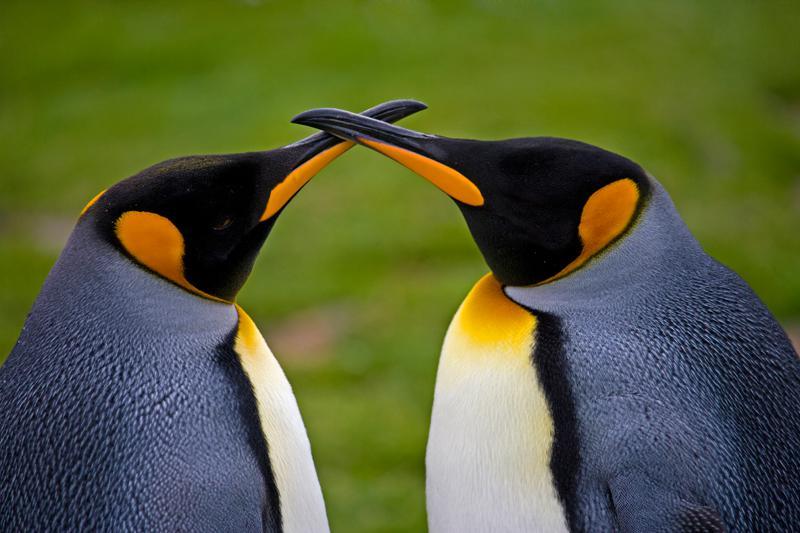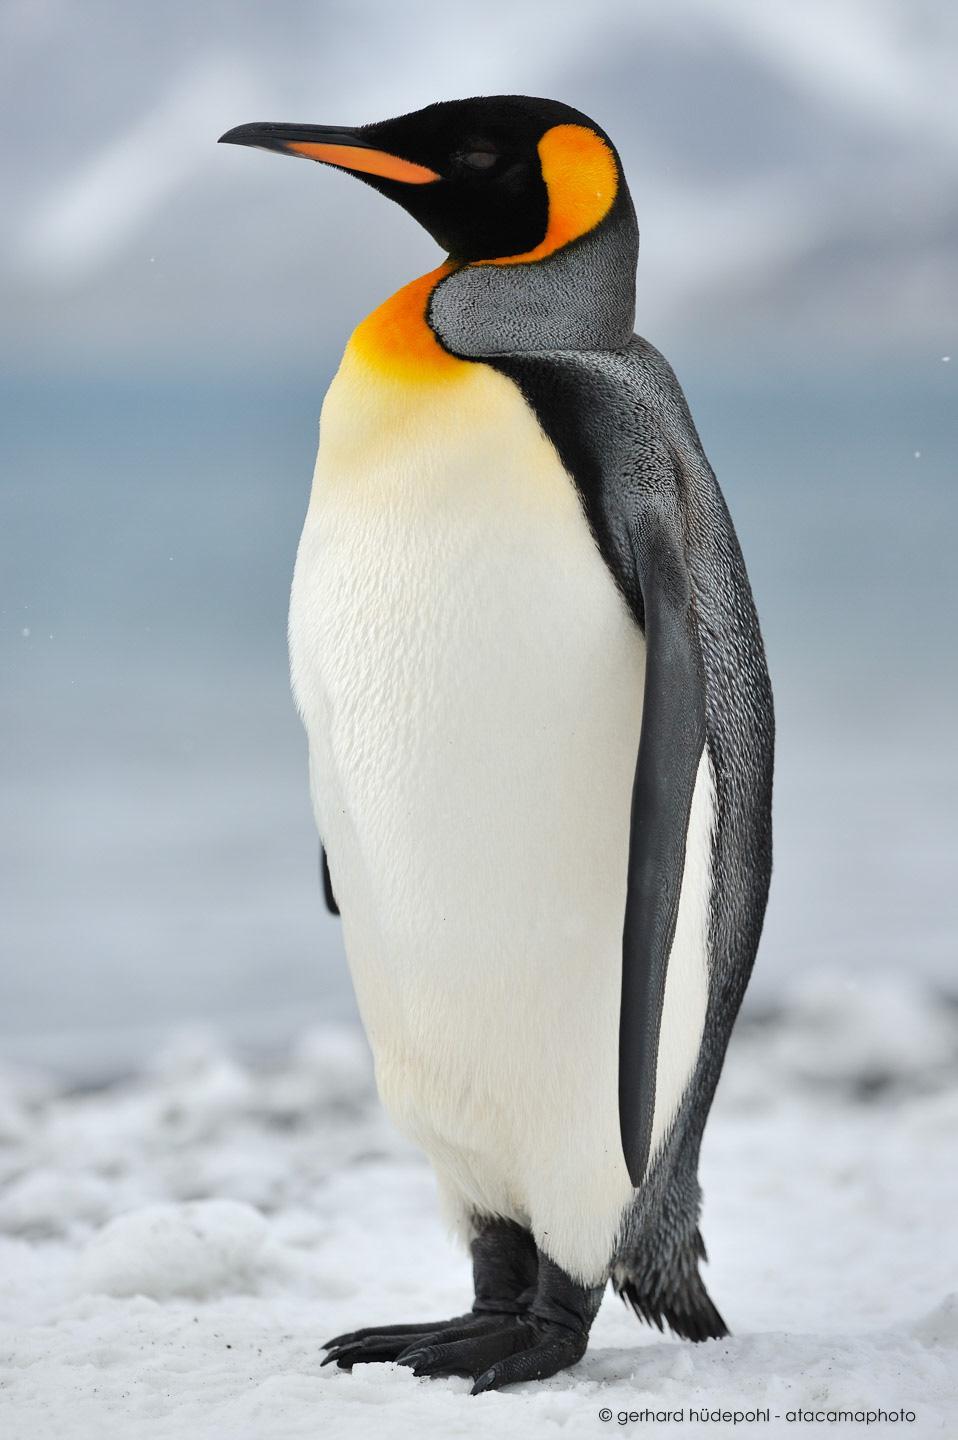The first image is the image on the left, the second image is the image on the right. Assess this claim about the two images: "A total of two penguins are on both images.". Correct or not? Answer yes or no. No. 